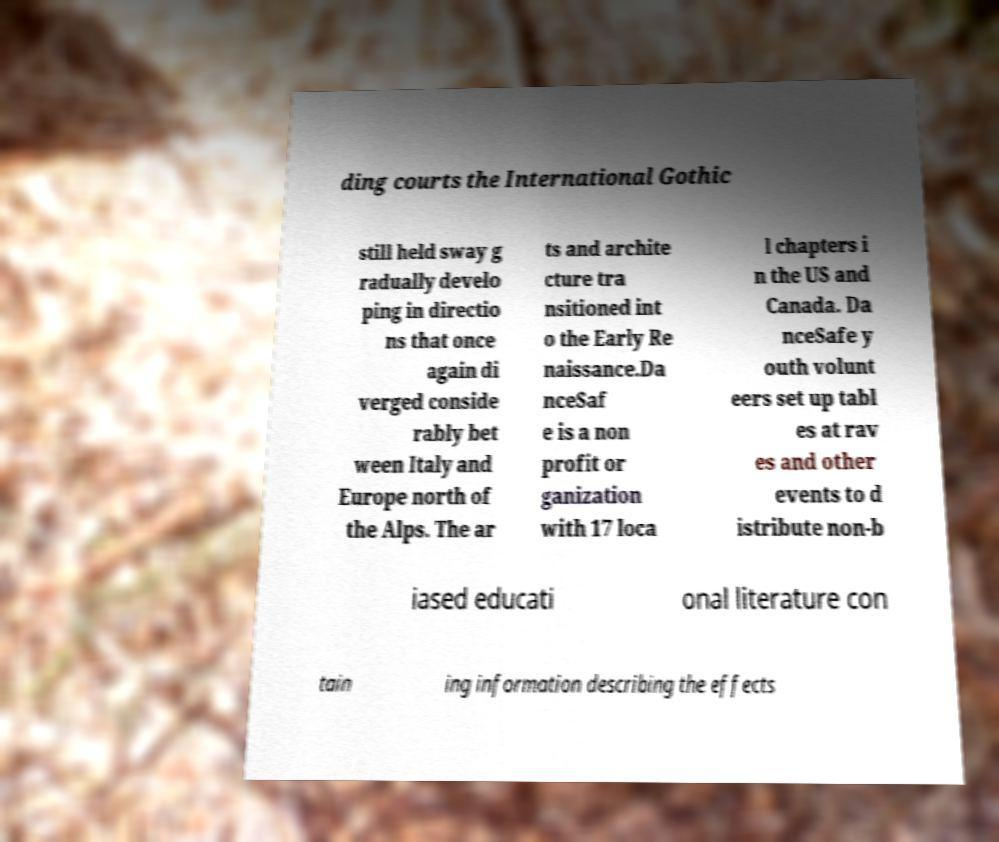Could you assist in decoding the text presented in this image and type it out clearly? ding courts the International Gothic still held sway g radually develo ping in directio ns that once again di verged conside rably bet ween Italy and Europe north of the Alps. The ar ts and archite cture tra nsitioned int o the Early Re naissance.Da nceSaf e is a non profit or ganization with 17 loca l chapters i n the US and Canada. Da nceSafe y outh volunt eers set up tabl es at rav es and other events to d istribute non-b iased educati onal literature con tain ing information describing the effects 